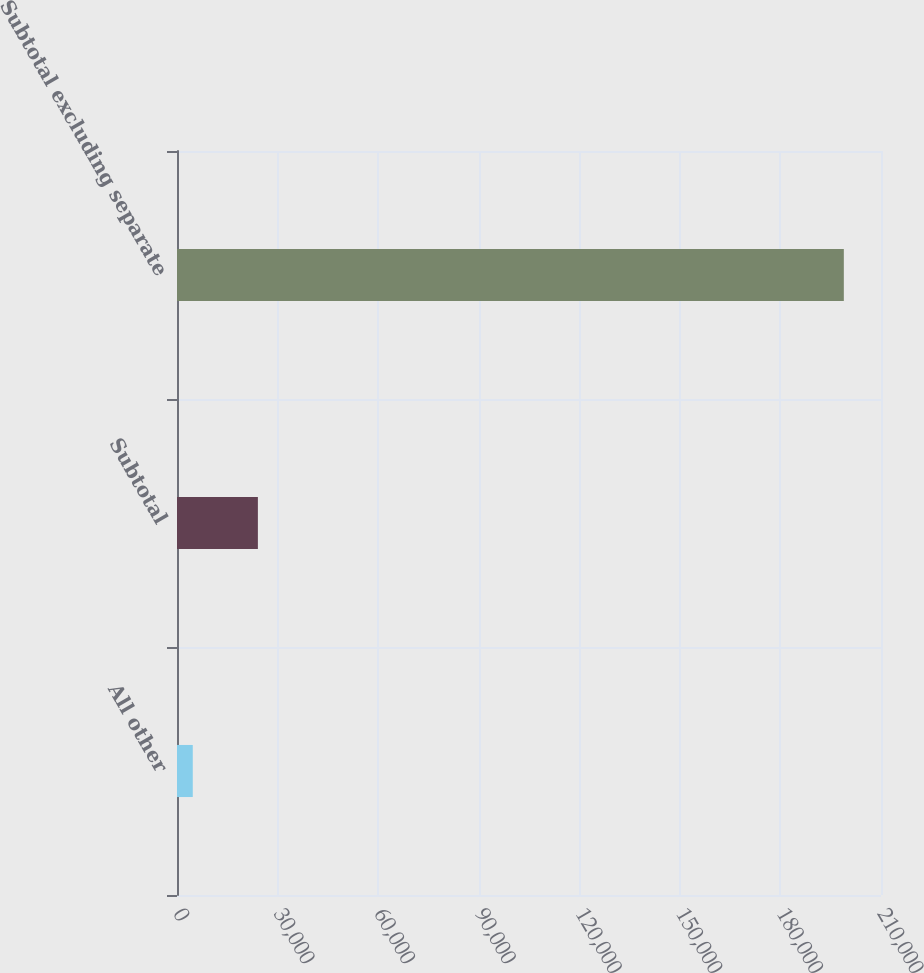Convert chart. <chart><loc_0><loc_0><loc_500><loc_500><bar_chart><fcel>All other<fcel>Subtotal<fcel>Subtotal excluding separate<nl><fcel>4707<fcel>24127.3<fcel>198910<nl></chart> 